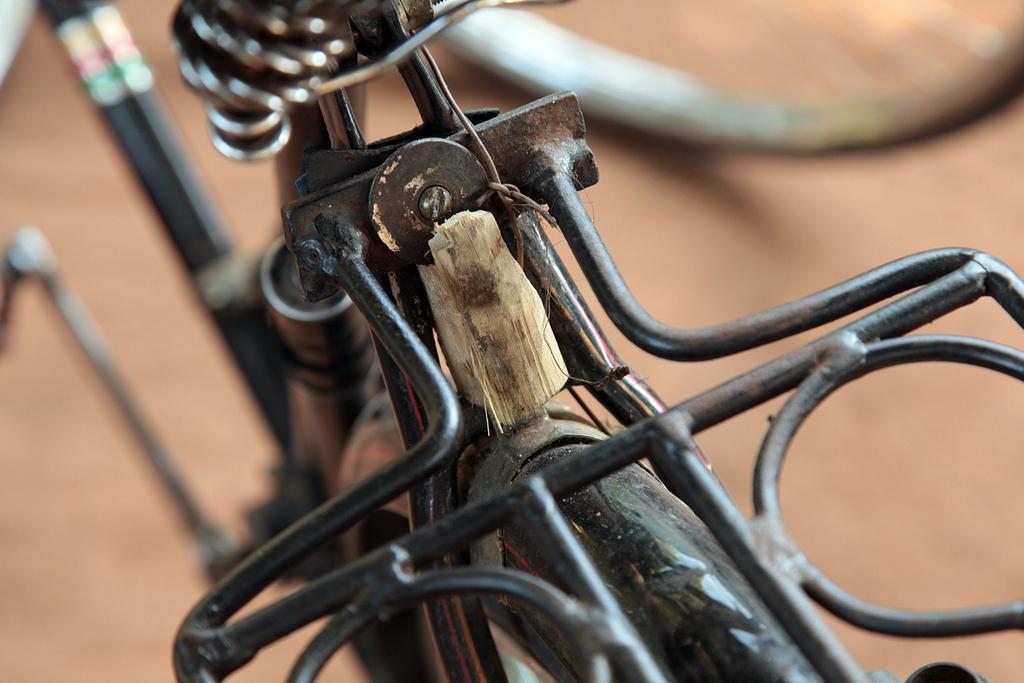In one or two sentences, can you explain what this image depicts? In the picture there is a bicycle present. 